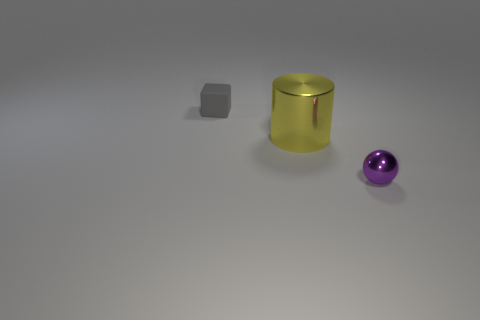What number of yellow metallic objects are on the right side of the small thing left of the thing in front of the yellow shiny cylinder?
Keep it short and to the point. 1. Is the number of purple metal objects greater than the number of big purple matte balls?
Make the answer very short. Yes. How many big yellow metallic things are there?
Offer a very short reply. 1. What is the shape of the metallic thing that is in front of the metallic object that is to the left of the tiny object that is in front of the tiny gray matte cube?
Offer a very short reply. Sphere. Are there fewer cylinders that are on the right side of the purple shiny object than gray matte things in front of the small rubber cube?
Your answer should be very brief. No. Does the object on the left side of the big yellow shiny cylinder have the same shape as the object in front of the large cylinder?
Your answer should be compact. No. What shape is the object that is in front of the metal thing left of the tiny purple thing?
Give a very brief answer. Sphere. Is there another large cyan ball made of the same material as the sphere?
Provide a succinct answer. No. There is a object behind the large yellow thing; what is it made of?
Offer a very short reply. Rubber. What material is the small gray thing?
Offer a terse response. Rubber. 